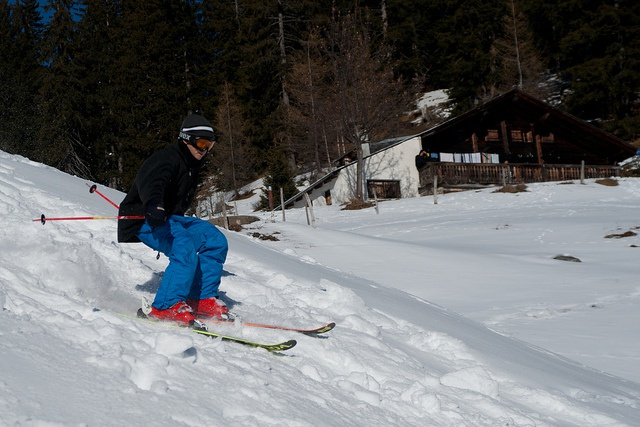Describe the objects in this image and their specific colors. I can see people in black, blue, navy, and darkblue tones, skis in black, darkgray, lightgray, and gray tones, and people in black, maroon, gray, and darkgray tones in this image. 